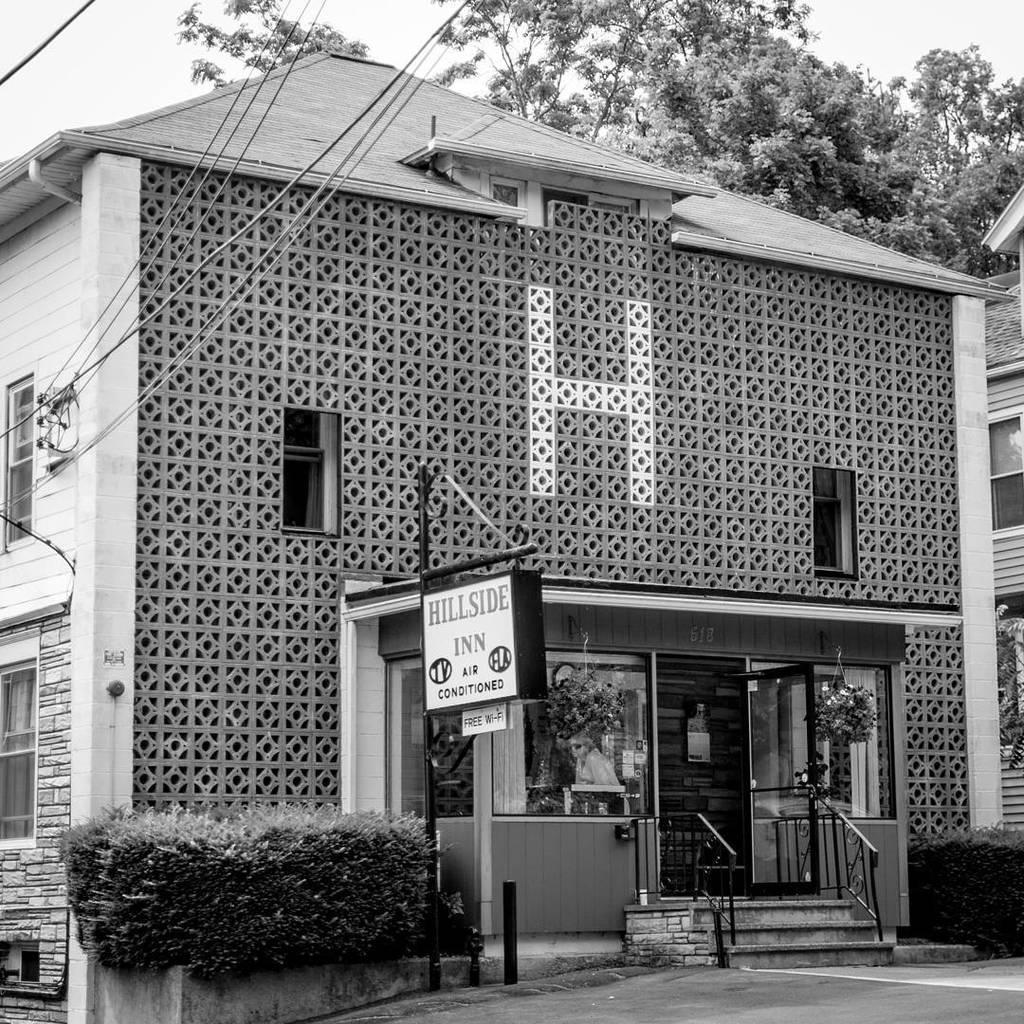Could you give a brief overview of what you see in this image? There are plants and a board is present at the bottom of this image. We can see a building in the middle of this image. There are trees at the top of this image and the sky is in the background. 